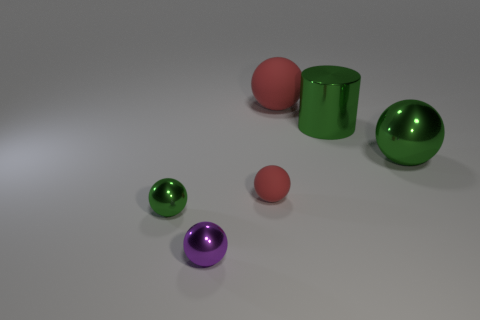Is the number of tiny balls greater than the number of small purple rubber blocks?
Provide a succinct answer. Yes. Is the tiny red thing made of the same material as the tiny green thing?
Your response must be concise. No. How many shiny things are large red things or large red cubes?
Make the answer very short. 0. What is the color of the metallic object that is the same size as the green cylinder?
Give a very brief answer. Green. What number of large yellow objects have the same shape as the small green object?
Give a very brief answer. 0. How many cylinders are either tiny red things or big objects?
Provide a short and direct response. 1. There is a tiny thing on the left side of the tiny purple ball; does it have the same shape as the big metal object behind the large metallic sphere?
Your response must be concise. No. What is the material of the purple thing?
Your response must be concise. Metal. The tiny object that is the same color as the large cylinder is what shape?
Give a very brief answer. Sphere. What number of metal spheres have the same size as the cylinder?
Your answer should be compact. 1. 